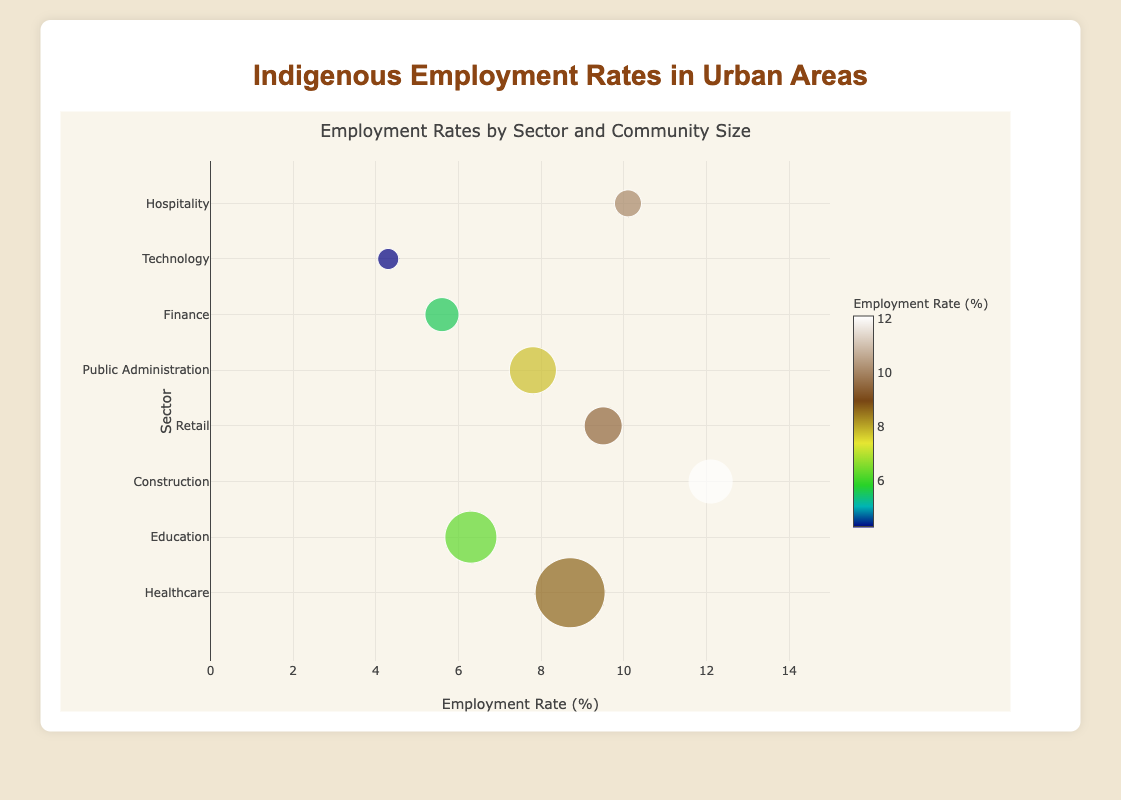How many different sectors are represented in the figure? The sectors in the figure include Healthcare, Education, Construction, Retail, Public Administration, Finance, Technology, and Hospitality.
Answer: 8 Which community has the highest employment rate? The community with the highest employment rate can be identified by the highest bubble along the x-axis. The Sioux community in the Construction sector has the highest employment rate at 12.1%.
Answer: Sioux What is the employment rate difference between the Finance and Technology sectors? The Finance sector's employment rate is 5.6%, and the Technology sector’s employment rate is 4.3%. The difference can be found by subtracting 4.3 from 5.6.
Answer: 1.3% Which city corresponds to the largest bubble and what sector is it in? The largest bubble represents the greatest population size. The city is Albuquerque, and the sector is Healthcare.
Answer: Albuquerque, Healthcare Which sector has the smallest population among the listed communities? The smallest bubble represents the smallest population size, which belongs to the Technology sector (Inuit community in Vancouver) with a population of 2100.
Answer: Technology Compare the employment rate of the Retail and Hospitality sectors. Which has a higher rate? The Retail sector (Ojibwe community in Minneapolis) has an employment rate of 9.5%, while the Hospitality sector (Apache community in Phoenix) has an employment rate of 10.1%. The Hospitality sector has a higher employment rate.
Answer: Hospitality What is the color scale used to represent the employment rates? The color scale is represented by a gradient that goes from lower employment rates to higher employment rates. This is specified as "Earth" colorscale.
Answer: Earth Which community has the lowest employment rate and what sector do they belong to? The community with the lowest employment rate can be identified by the smallest value along the x-axis. The Inuit community in the Technology sector has the lowest employment rate at 4.3%.
Answer: Inuit, Technology What is the average employment rate across all sectors? To find the average employment rate, add all the employment rates and divide by the number of sectors: (8.7 + 6.3 + 12.1 + 9.5 + 7.8 + 5.6 + 4.3 + 10.1) / 8 = 64.4 / 8.
Answer: 8.05% Which sector has a larger bubble size: Retail or Education? Compare the bubble sizes for the Retail sector (population of 3800) and the Education sector (population of 5200). The Education sector has a larger bubble size.
Answer: Education 